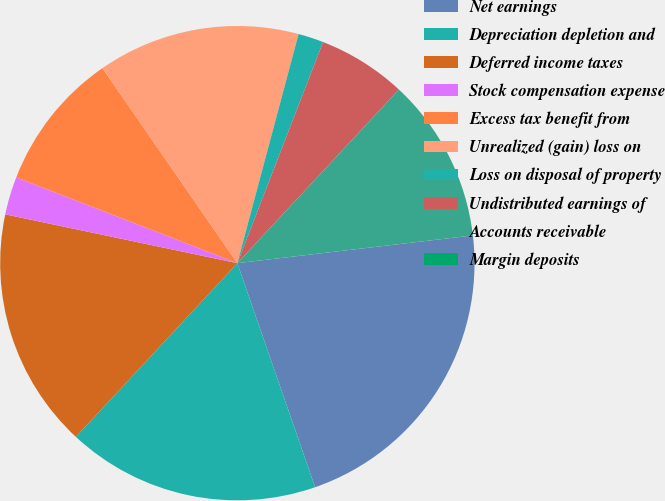Convert chart to OTSL. <chart><loc_0><loc_0><loc_500><loc_500><pie_chart><fcel>Net earnings<fcel>Depreciation depletion and<fcel>Deferred income taxes<fcel>Stock compensation expense<fcel>Excess tax benefit from<fcel>Unrealized (gain) loss on<fcel>Loss on disposal of property<fcel>Undistributed earnings of<fcel>Accounts receivable<fcel>Margin deposits<nl><fcel>21.55%<fcel>17.24%<fcel>16.38%<fcel>2.59%<fcel>9.48%<fcel>13.79%<fcel>1.73%<fcel>6.04%<fcel>11.21%<fcel>0.0%<nl></chart> 